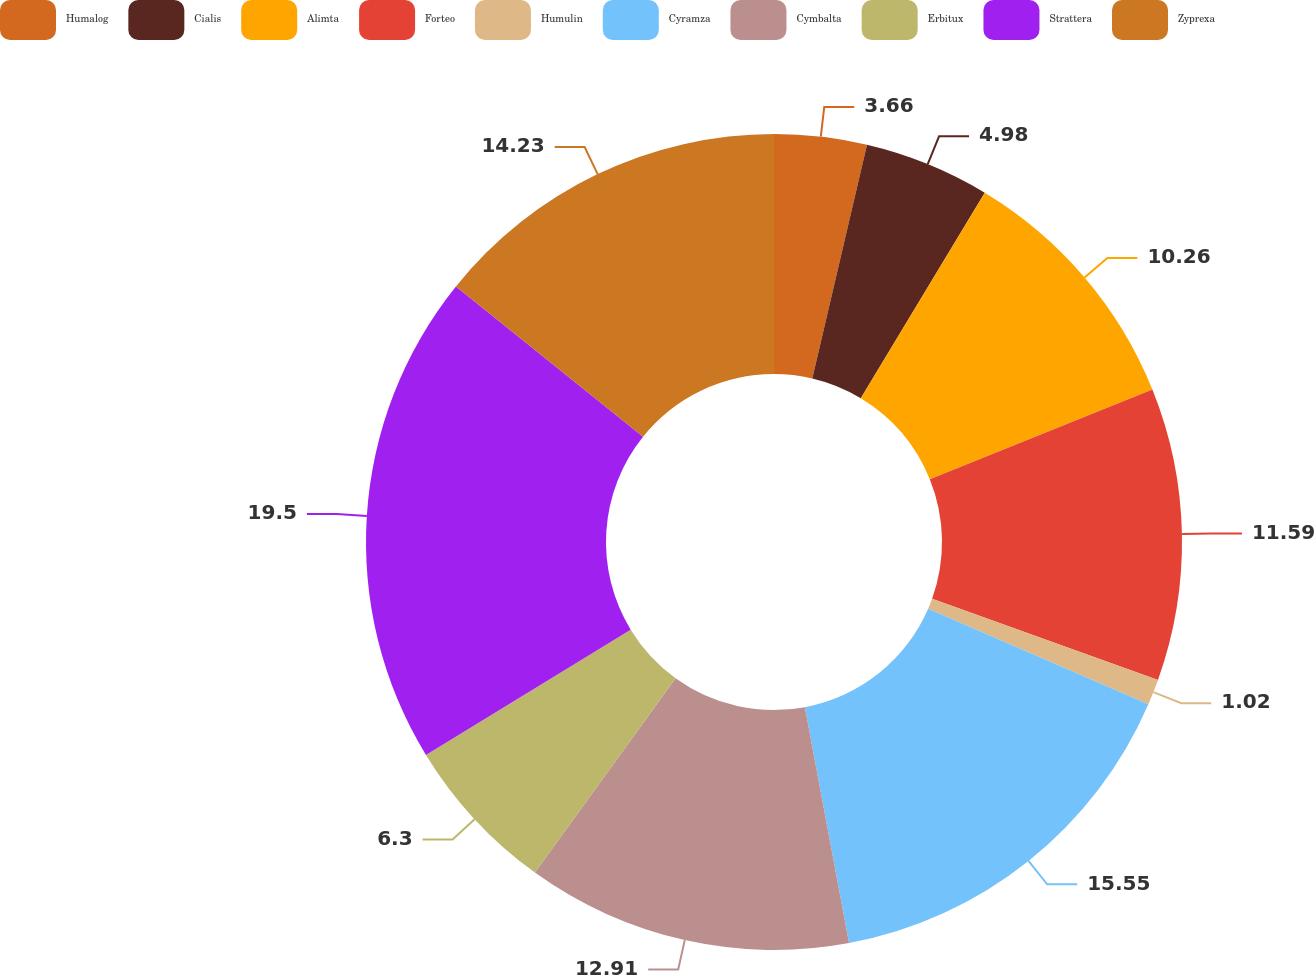Convert chart. <chart><loc_0><loc_0><loc_500><loc_500><pie_chart><fcel>Humalog<fcel>Cialis<fcel>Alimta<fcel>Forteo<fcel>Humulin<fcel>Cyramza<fcel>Cymbalta<fcel>Erbitux<fcel>Strattera<fcel>Zyprexa<nl><fcel>3.66%<fcel>4.98%<fcel>10.26%<fcel>11.59%<fcel>1.02%<fcel>15.55%<fcel>12.91%<fcel>6.3%<fcel>19.51%<fcel>14.23%<nl></chart> 